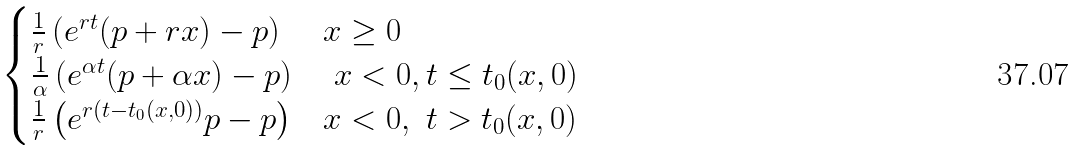Convert formula to latex. <formula><loc_0><loc_0><loc_500><loc_500>\begin{cases} \frac { 1 } { r } \left ( e ^ { r t } ( p + r x ) - p \right ) & x \geq 0 \\ \frac { 1 } { \alpha } \left ( e ^ { \alpha t } ( p + \alpha x ) - p \right ) & \ x < 0 , t \leq t _ { 0 } ( x , 0 ) \\ \frac { 1 } { r } \left ( e ^ { r ( t - t _ { 0 } ( x , 0 ) ) } p - p \right ) & x < 0 , \ t > t _ { 0 } ( x , 0 ) \end{cases}</formula> 